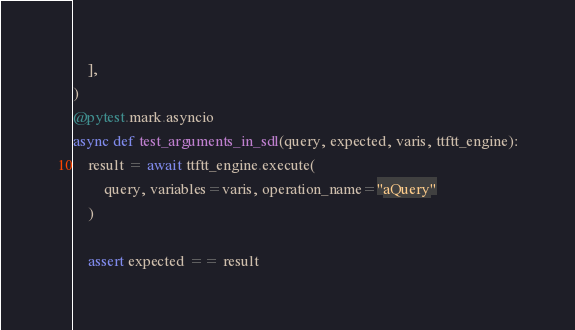Convert code to text. <code><loc_0><loc_0><loc_500><loc_500><_Python_>    ],
)
@pytest.mark.asyncio
async def test_arguments_in_sdl(query, expected, varis, ttftt_engine):
    result = await ttftt_engine.execute(
        query, variables=varis, operation_name="aQuery"
    )

    assert expected == result
</code> 